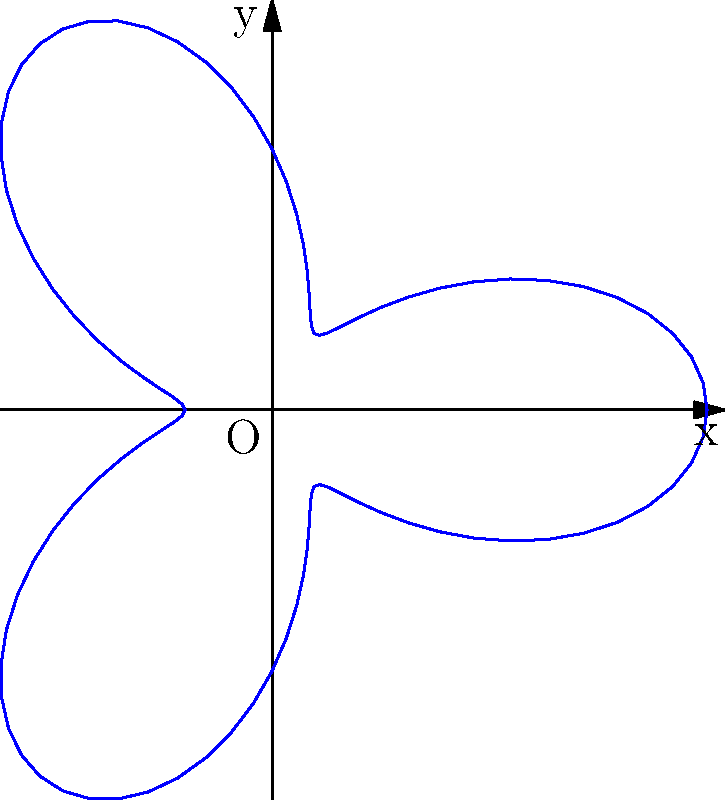In a recent match, Messi's movement pattern on the field was tracked and represented using polar coordinates. The equation $r = 3 + 2\cos(3\theta)$ describes the boundary of the area he covered during the game, where $r$ is in meters. Calculate the total area, in square meters, that Messi covered during this match. To find the area covered by Messi's movement, we need to use the formula for the area enclosed by a polar curve:

$$A = \frac{1}{2} \int_{0}^{2\pi} r^2 d\theta$$

Given: $r = 3 + 2\cos(3\theta)$

Step 1: Square the radius function:
$$r^2 = (3 + 2\cos(3\theta))^2 = 9 + 12\cos(3\theta) + 4\cos^2(3\theta)$$

Step 2: Integrate $r^2$ from 0 to $2\pi$:
$$A = \frac{1}{2} \int_{0}^{2\pi} (9 + 12\cos(3\theta) + 4\cos^2(3\theta)) d\theta$$

Step 3: Integrate each term:
- $\int_{0}^{2\pi} 9 d\theta = 9\theta |_{0}^{2\pi} = 18\pi$
- $\int_{0}^{2\pi} 12\cos(3\theta) d\theta = 4\sin(3\theta) |_{0}^{2\pi} = 0$
- $\int_{0}^{2\pi} 4\cos^2(3\theta) d\theta = 2\theta + \frac{2}{3}\sin(6\theta) |_{0}^{2\pi} = 4\pi$

Step 4: Sum up the results and multiply by $\frac{1}{2}$:
$$A = \frac{1}{2} (18\pi + 0 + 4\pi) = 11\pi$$

Therefore, the total area covered by Messi during the match is $11\pi$ square meters.
Answer: $11\pi$ square meters 